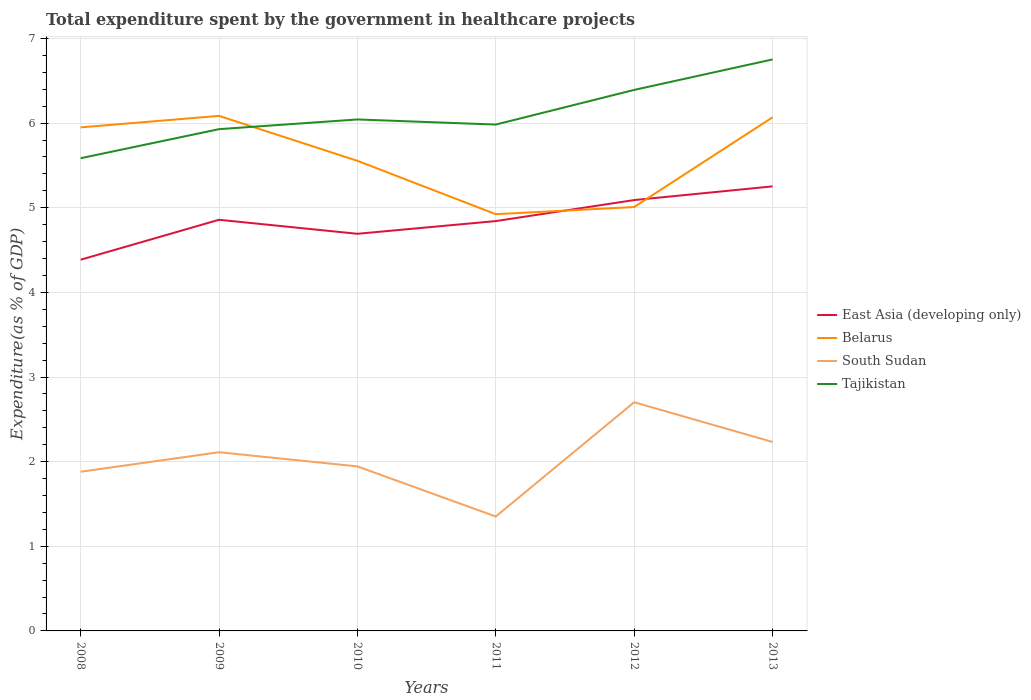Is the number of lines equal to the number of legend labels?
Your answer should be very brief. Yes. Across all years, what is the maximum total expenditure spent by the government in healthcare projects in Tajikistan?
Provide a succinct answer. 5.58. In which year was the total expenditure spent by the government in healthcare projects in Tajikistan maximum?
Ensure brevity in your answer.  2008. What is the total total expenditure spent by the government in healthcare projects in Tajikistan in the graph?
Offer a very short reply. -0.36. What is the difference between the highest and the second highest total expenditure spent by the government in healthcare projects in East Asia (developing only)?
Provide a succinct answer. 0.87. Is the total expenditure spent by the government in healthcare projects in East Asia (developing only) strictly greater than the total expenditure spent by the government in healthcare projects in Tajikistan over the years?
Your answer should be very brief. Yes. How many lines are there?
Offer a terse response. 4. What is the difference between two consecutive major ticks on the Y-axis?
Keep it short and to the point. 1. Does the graph contain any zero values?
Ensure brevity in your answer.  No. Where does the legend appear in the graph?
Offer a terse response. Center right. What is the title of the graph?
Give a very brief answer. Total expenditure spent by the government in healthcare projects. What is the label or title of the X-axis?
Offer a very short reply. Years. What is the label or title of the Y-axis?
Keep it short and to the point. Expenditure(as % of GDP). What is the Expenditure(as % of GDP) in East Asia (developing only) in 2008?
Your answer should be very brief. 4.39. What is the Expenditure(as % of GDP) in Belarus in 2008?
Ensure brevity in your answer.  5.95. What is the Expenditure(as % of GDP) of South Sudan in 2008?
Provide a succinct answer. 1.88. What is the Expenditure(as % of GDP) in Tajikistan in 2008?
Keep it short and to the point. 5.58. What is the Expenditure(as % of GDP) in East Asia (developing only) in 2009?
Make the answer very short. 4.86. What is the Expenditure(as % of GDP) of Belarus in 2009?
Provide a succinct answer. 6.09. What is the Expenditure(as % of GDP) of South Sudan in 2009?
Your response must be concise. 2.11. What is the Expenditure(as % of GDP) in Tajikistan in 2009?
Offer a very short reply. 5.93. What is the Expenditure(as % of GDP) of East Asia (developing only) in 2010?
Offer a terse response. 4.69. What is the Expenditure(as % of GDP) in Belarus in 2010?
Make the answer very short. 5.55. What is the Expenditure(as % of GDP) in South Sudan in 2010?
Make the answer very short. 1.94. What is the Expenditure(as % of GDP) of Tajikistan in 2010?
Your answer should be very brief. 6.04. What is the Expenditure(as % of GDP) in East Asia (developing only) in 2011?
Give a very brief answer. 4.84. What is the Expenditure(as % of GDP) in Belarus in 2011?
Provide a succinct answer. 4.92. What is the Expenditure(as % of GDP) in South Sudan in 2011?
Make the answer very short. 1.35. What is the Expenditure(as % of GDP) in Tajikistan in 2011?
Your response must be concise. 5.98. What is the Expenditure(as % of GDP) of East Asia (developing only) in 2012?
Your answer should be compact. 5.09. What is the Expenditure(as % of GDP) in Belarus in 2012?
Keep it short and to the point. 5.01. What is the Expenditure(as % of GDP) of South Sudan in 2012?
Give a very brief answer. 2.7. What is the Expenditure(as % of GDP) in Tajikistan in 2012?
Your answer should be compact. 6.39. What is the Expenditure(as % of GDP) in East Asia (developing only) in 2013?
Ensure brevity in your answer.  5.25. What is the Expenditure(as % of GDP) in Belarus in 2013?
Offer a terse response. 6.07. What is the Expenditure(as % of GDP) in South Sudan in 2013?
Your response must be concise. 2.23. What is the Expenditure(as % of GDP) of Tajikistan in 2013?
Your response must be concise. 6.75. Across all years, what is the maximum Expenditure(as % of GDP) in East Asia (developing only)?
Make the answer very short. 5.25. Across all years, what is the maximum Expenditure(as % of GDP) of Belarus?
Ensure brevity in your answer.  6.09. Across all years, what is the maximum Expenditure(as % of GDP) of South Sudan?
Give a very brief answer. 2.7. Across all years, what is the maximum Expenditure(as % of GDP) in Tajikistan?
Give a very brief answer. 6.75. Across all years, what is the minimum Expenditure(as % of GDP) in East Asia (developing only)?
Ensure brevity in your answer.  4.39. Across all years, what is the minimum Expenditure(as % of GDP) of Belarus?
Your answer should be very brief. 4.92. Across all years, what is the minimum Expenditure(as % of GDP) in South Sudan?
Provide a succinct answer. 1.35. Across all years, what is the minimum Expenditure(as % of GDP) of Tajikistan?
Your answer should be very brief. 5.58. What is the total Expenditure(as % of GDP) in East Asia (developing only) in the graph?
Offer a terse response. 29.12. What is the total Expenditure(as % of GDP) of Belarus in the graph?
Offer a very short reply. 33.59. What is the total Expenditure(as % of GDP) in South Sudan in the graph?
Make the answer very short. 12.22. What is the total Expenditure(as % of GDP) in Tajikistan in the graph?
Ensure brevity in your answer.  36.68. What is the difference between the Expenditure(as % of GDP) of East Asia (developing only) in 2008 and that in 2009?
Provide a short and direct response. -0.47. What is the difference between the Expenditure(as % of GDP) of Belarus in 2008 and that in 2009?
Provide a short and direct response. -0.14. What is the difference between the Expenditure(as % of GDP) in South Sudan in 2008 and that in 2009?
Your answer should be compact. -0.23. What is the difference between the Expenditure(as % of GDP) of Tajikistan in 2008 and that in 2009?
Your answer should be very brief. -0.34. What is the difference between the Expenditure(as % of GDP) in East Asia (developing only) in 2008 and that in 2010?
Provide a succinct answer. -0.31. What is the difference between the Expenditure(as % of GDP) of Belarus in 2008 and that in 2010?
Offer a terse response. 0.4. What is the difference between the Expenditure(as % of GDP) in South Sudan in 2008 and that in 2010?
Offer a terse response. -0.06. What is the difference between the Expenditure(as % of GDP) of Tajikistan in 2008 and that in 2010?
Give a very brief answer. -0.46. What is the difference between the Expenditure(as % of GDP) of East Asia (developing only) in 2008 and that in 2011?
Your response must be concise. -0.46. What is the difference between the Expenditure(as % of GDP) of Belarus in 2008 and that in 2011?
Provide a short and direct response. 1.03. What is the difference between the Expenditure(as % of GDP) in South Sudan in 2008 and that in 2011?
Offer a terse response. 0.53. What is the difference between the Expenditure(as % of GDP) in Tajikistan in 2008 and that in 2011?
Provide a succinct answer. -0.4. What is the difference between the Expenditure(as % of GDP) of East Asia (developing only) in 2008 and that in 2012?
Provide a short and direct response. -0.7. What is the difference between the Expenditure(as % of GDP) in Belarus in 2008 and that in 2012?
Your answer should be compact. 0.94. What is the difference between the Expenditure(as % of GDP) in South Sudan in 2008 and that in 2012?
Ensure brevity in your answer.  -0.82. What is the difference between the Expenditure(as % of GDP) in Tajikistan in 2008 and that in 2012?
Give a very brief answer. -0.81. What is the difference between the Expenditure(as % of GDP) of East Asia (developing only) in 2008 and that in 2013?
Ensure brevity in your answer.  -0.87. What is the difference between the Expenditure(as % of GDP) of Belarus in 2008 and that in 2013?
Your response must be concise. -0.12. What is the difference between the Expenditure(as % of GDP) of South Sudan in 2008 and that in 2013?
Make the answer very short. -0.35. What is the difference between the Expenditure(as % of GDP) in Tajikistan in 2008 and that in 2013?
Your answer should be compact. -1.17. What is the difference between the Expenditure(as % of GDP) of East Asia (developing only) in 2009 and that in 2010?
Offer a terse response. 0.17. What is the difference between the Expenditure(as % of GDP) of Belarus in 2009 and that in 2010?
Offer a very short reply. 0.53. What is the difference between the Expenditure(as % of GDP) in South Sudan in 2009 and that in 2010?
Offer a terse response. 0.17. What is the difference between the Expenditure(as % of GDP) in Tajikistan in 2009 and that in 2010?
Provide a short and direct response. -0.11. What is the difference between the Expenditure(as % of GDP) of East Asia (developing only) in 2009 and that in 2011?
Make the answer very short. 0.02. What is the difference between the Expenditure(as % of GDP) in Belarus in 2009 and that in 2011?
Your answer should be compact. 1.16. What is the difference between the Expenditure(as % of GDP) in South Sudan in 2009 and that in 2011?
Ensure brevity in your answer.  0.76. What is the difference between the Expenditure(as % of GDP) of Tajikistan in 2009 and that in 2011?
Keep it short and to the point. -0.05. What is the difference between the Expenditure(as % of GDP) in East Asia (developing only) in 2009 and that in 2012?
Provide a succinct answer. -0.23. What is the difference between the Expenditure(as % of GDP) in Belarus in 2009 and that in 2012?
Give a very brief answer. 1.08. What is the difference between the Expenditure(as % of GDP) of South Sudan in 2009 and that in 2012?
Provide a short and direct response. -0.59. What is the difference between the Expenditure(as % of GDP) in Tajikistan in 2009 and that in 2012?
Provide a short and direct response. -0.46. What is the difference between the Expenditure(as % of GDP) of East Asia (developing only) in 2009 and that in 2013?
Provide a short and direct response. -0.39. What is the difference between the Expenditure(as % of GDP) of Belarus in 2009 and that in 2013?
Provide a succinct answer. 0.02. What is the difference between the Expenditure(as % of GDP) of South Sudan in 2009 and that in 2013?
Make the answer very short. -0.12. What is the difference between the Expenditure(as % of GDP) of Tajikistan in 2009 and that in 2013?
Offer a terse response. -0.82. What is the difference between the Expenditure(as % of GDP) in East Asia (developing only) in 2010 and that in 2011?
Make the answer very short. -0.15. What is the difference between the Expenditure(as % of GDP) in Belarus in 2010 and that in 2011?
Your answer should be very brief. 0.63. What is the difference between the Expenditure(as % of GDP) of South Sudan in 2010 and that in 2011?
Make the answer very short. 0.59. What is the difference between the Expenditure(as % of GDP) of Tajikistan in 2010 and that in 2011?
Offer a very short reply. 0.06. What is the difference between the Expenditure(as % of GDP) in East Asia (developing only) in 2010 and that in 2012?
Provide a succinct answer. -0.4. What is the difference between the Expenditure(as % of GDP) of Belarus in 2010 and that in 2012?
Ensure brevity in your answer.  0.55. What is the difference between the Expenditure(as % of GDP) of South Sudan in 2010 and that in 2012?
Keep it short and to the point. -0.76. What is the difference between the Expenditure(as % of GDP) in Tajikistan in 2010 and that in 2012?
Offer a terse response. -0.35. What is the difference between the Expenditure(as % of GDP) of East Asia (developing only) in 2010 and that in 2013?
Offer a very short reply. -0.56. What is the difference between the Expenditure(as % of GDP) of Belarus in 2010 and that in 2013?
Your answer should be compact. -0.51. What is the difference between the Expenditure(as % of GDP) of South Sudan in 2010 and that in 2013?
Offer a very short reply. -0.29. What is the difference between the Expenditure(as % of GDP) of Tajikistan in 2010 and that in 2013?
Offer a terse response. -0.71. What is the difference between the Expenditure(as % of GDP) in East Asia (developing only) in 2011 and that in 2012?
Make the answer very short. -0.25. What is the difference between the Expenditure(as % of GDP) in Belarus in 2011 and that in 2012?
Your response must be concise. -0.08. What is the difference between the Expenditure(as % of GDP) in South Sudan in 2011 and that in 2012?
Offer a terse response. -1.35. What is the difference between the Expenditure(as % of GDP) of Tajikistan in 2011 and that in 2012?
Your answer should be very brief. -0.41. What is the difference between the Expenditure(as % of GDP) in East Asia (developing only) in 2011 and that in 2013?
Give a very brief answer. -0.41. What is the difference between the Expenditure(as % of GDP) in Belarus in 2011 and that in 2013?
Ensure brevity in your answer.  -1.14. What is the difference between the Expenditure(as % of GDP) in South Sudan in 2011 and that in 2013?
Keep it short and to the point. -0.88. What is the difference between the Expenditure(as % of GDP) of Tajikistan in 2011 and that in 2013?
Ensure brevity in your answer.  -0.77. What is the difference between the Expenditure(as % of GDP) of East Asia (developing only) in 2012 and that in 2013?
Ensure brevity in your answer.  -0.16. What is the difference between the Expenditure(as % of GDP) of Belarus in 2012 and that in 2013?
Provide a succinct answer. -1.06. What is the difference between the Expenditure(as % of GDP) in South Sudan in 2012 and that in 2013?
Make the answer very short. 0.47. What is the difference between the Expenditure(as % of GDP) in Tajikistan in 2012 and that in 2013?
Give a very brief answer. -0.36. What is the difference between the Expenditure(as % of GDP) of East Asia (developing only) in 2008 and the Expenditure(as % of GDP) of Belarus in 2009?
Keep it short and to the point. -1.7. What is the difference between the Expenditure(as % of GDP) in East Asia (developing only) in 2008 and the Expenditure(as % of GDP) in South Sudan in 2009?
Provide a short and direct response. 2.27. What is the difference between the Expenditure(as % of GDP) in East Asia (developing only) in 2008 and the Expenditure(as % of GDP) in Tajikistan in 2009?
Provide a short and direct response. -1.54. What is the difference between the Expenditure(as % of GDP) in Belarus in 2008 and the Expenditure(as % of GDP) in South Sudan in 2009?
Make the answer very short. 3.84. What is the difference between the Expenditure(as % of GDP) in Belarus in 2008 and the Expenditure(as % of GDP) in Tajikistan in 2009?
Make the answer very short. 0.02. What is the difference between the Expenditure(as % of GDP) of South Sudan in 2008 and the Expenditure(as % of GDP) of Tajikistan in 2009?
Your answer should be compact. -4.05. What is the difference between the Expenditure(as % of GDP) of East Asia (developing only) in 2008 and the Expenditure(as % of GDP) of Belarus in 2010?
Provide a succinct answer. -1.17. What is the difference between the Expenditure(as % of GDP) in East Asia (developing only) in 2008 and the Expenditure(as % of GDP) in South Sudan in 2010?
Your answer should be compact. 2.44. What is the difference between the Expenditure(as % of GDP) of East Asia (developing only) in 2008 and the Expenditure(as % of GDP) of Tajikistan in 2010?
Offer a terse response. -1.66. What is the difference between the Expenditure(as % of GDP) in Belarus in 2008 and the Expenditure(as % of GDP) in South Sudan in 2010?
Your response must be concise. 4.01. What is the difference between the Expenditure(as % of GDP) of Belarus in 2008 and the Expenditure(as % of GDP) of Tajikistan in 2010?
Ensure brevity in your answer.  -0.09. What is the difference between the Expenditure(as % of GDP) in South Sudan in 2008 and the Expenditure(as % of GDP) in Tajikistan in 2010?
Offer a very short reply. -4.16. What is the difference between the Expenditure(as % of GDP) of East Asia (developing only) in 2008 and the Expenditure(as % of GDP) of Belarus in 2011?
Your answer should be very brief. -0.54. What is the difference between the Expenditure(as % of GDP) in East Asia (developing only) in 2008 and the Expenditure(as % of GDP) in South Sudan in 2011?
Offer a terse response. 3.03. What is the difference between the Expenditure(as % of GDP) of East Asia (developing only) in 2008 and the Expenditure(as % of GDP) of Tajikistan in 2011?
Ensure brevity in your answer.  -1.6. What is the difference between the Expenditure(as % of GDP) of Belarus in 2008 and the Expenditure(as % of GDP) of South Sudan in 2011?
Keep it short and to the point. 4.6. What is the difference between the Expenditure(as % of GDP) in Belarus in 2008 and the Expenditure(as % of GDP) in Tajikistan in 2011?
Keep it short and to the point. -0.03. What is the difference between the Expenditure(as % of GDP) in South Sudan in 2008 and the Expenditure(as % of GDP) in Tajikistan in 2011?
Ensure brevity in your answer.  -4.1. What is the difference between the Expenditure(as % of GDP) of East Asia (developing only) in 2008 and the Expenditure(as % of GDP) of Belarus in 2012?
Provide a succinct answer. -0.62. What is the difference between the Expenditure(as % of GDP) of East Asia (developing only) in 2008 and the Expenditure(as % of GDP) of South Sudan in 2012?
Keep it short and to the point. 1.68. What is the difference between the Expenditure(as % of GDP) of East Asia (developing only) in 2008 and the Expenditure(as % of GDP) of Tajikistan in 2012?
Offer a terse response. -2.01. What is the difference between the Expenditure(as % of GDP) in Belarus in 2008 and the Expenditure(as % of GDP) in South Sudan in 2012?
Provide a succinct answer. 3.25. What is the difference between the Expenditure(as % of GDP) in Belarus in 2008 and the Expenditure(as % of GDP) in Tajikistan in 2012?
Offer a very short reply. -0.44. What is the difference between the Expenditure(as % of GDP) of South Sudan in 2008 and the Expenditure(as % of GDP) of Tajikistan in 2012?
Your answer should be compact. -4.51. What is the difference between the Expenditure(as % of GDP) of East Asia (developing only) in 2008 and the Expenditure(as % of GDP) of Belarus in 2013?
Keep it short and to the point. -1.68. What is the difference between the Expenditure(as % of GDP) of East Asia (developing only) in 2008 and the Expenditure(as % of GDP) of South Sudan in 2013?
Offer a terse response. 2.15. What is the difference between the Expenditure(as % of GDP) in East Asia (developing only) in 2008 and the Expenditure(as % of GDP) in Tajikistan in 2013?
Ensure brevity in your answer.  -2.37. What is the difference between the Expenditure(as % of GDP) of Belarus in 2008 and the Expenditure(as % of GDP) of South Sudan in 2013?
Offer a very short reply. 3.72. What is the difference between the Expenditure(as % of GDP) of Belarus in 2008 and the Expenditure(as % of GDP) of Tajikistan in 2013?
Keep it short and to the point. -0.8. What is the difference between the Expenditure(as % of GDP) of South Sudan in 2008 and the Expenditure(as % of GDP) of Tajikistan in 2013?
Your response must be concise. -4.87. What is the difference between the Expenditure(as % of GDP) of East Asia (developing only) in 2009 and the Expenditure(as % of GDP) of Belarus in 2010?
Provide a short and direct response. -0.7. What is the difference between the Expenditure(as % of GDP) of East Asia (developing only) in 2009 and the Expenditure(as % of GDP) of South Sudan in 2010?
Provide a short and direct response. 2.91. What is the difference between the Expenditure(as % of GDP) in East Asia (developing only) in 2009 and the Expenditure(as % of GDP) in Tajikistan in 2010?
Keep it short and to the point. -1.19. What is the difference between the Expenditure(as % of GDP) of Belarus in 2009 and the Expenditure(as % of GDP) of South Sudan in 2010?
Offer a terse response. 4.14. What is the difference between the Expenditure(as % of GDP) of Belarus in 2009 and the Expenditure(as % of GDP) of Tajikistan in 2010?
Provide a short and direct response. 0.04. What is the difference between the Expenditure(as % of GDP) in South Sudan in 2009 and the Expenditure(as % of GDP) in Tajikistan in 2010?
Your answer should be very brief. -3.93. What is the difference between the Expenditure(as % of GDP) in East Asia (developing only) in 2009 and the Expenditure(as % of GDP) in Belarus in 2011?
Offer a very short reply. -0.07. What is the difference between the Expenditure(as % of GDP) in East Asia (developing only) in 2009 and the Expenditure(as % of GDP) in South Sudan in 2011?
Give a very brief answer. 3.51. What is the difference between the Expenditure(as % of GDP) of East Asia (developing only) in 2009 and the Expenditure(as % of GDP) of Tajikistan in 2011?
Provide a short and direct response. -1.12. What is the difference between the Expenditure(as % of GDP) in Belarus in 2009 and the Expenditure(as % of GDP) in South Sudan in 2011?
Ensure brevity in your answer.  4.73. What is the difference between the Expenditure(as % of GDP) in Belarus in 2009 and the Expenditure(as % of GDP) in Tajikistan in 2011?
Give a very brief answer. 0.1. What is the difference between the Expenditure(as % of GDP) in South Sudan in 2009 and the Expenditure(as % of GDP) in Tajikistan in 2011?
Your answer should be compact. -3.87. What is the difference between the Expenditure(as % of GDP) in East Asia (developing only) in 2009 and the Expenditure(as % of GDP) in Belarus in 2012?
Ensure brevity in your answer.  -0.15. What is the difference between the Expenditure(as % of GDP) in East Asia (developing only) in 2009 and the Expenditure(as % of GDP) in South Sudan in 2012?
Provide a succinct answer. 2.16. What is the difference between the Expenditure(as % of GDP) of East Asia (developing only) in 2009 and the Expenditure(as % of GDP) of Tajikistan in 2012?
Keep it short and to the point. -1.53. What is the difference between the Expenditure(as % of GDP) in Belarus in 2009 and the Expenditure(as % of GDP) in South Sudan in 2012?
Ensure brevity in your answer.  3.38. What is the difference between the Expenditure(as % of GDP) in Belarus in 2009 and the Expenditure(as % of GDP) in Tajikistan in 2012?
Give a very brief answer. -0.31. What is the difference between the Expenditure(as % of GDP) in South Sudan in 2009 and the Expenditure(as % of GDP) in Tajikistan in 2012?
Offer a terse response. -4.28. What is the difference between the Expenditure(as % of GDP) in East Asia (developing only) in 2009 and the Expenditure(as % of GDP) in Belarus in 2013?
Your answer should be compact. -1.21. What is the difference between the Expenditure(as % of GDP) in East Asia (developing only) in 2009 and the Expenditure(as % of GDP) in South Sudan in 2013?
Offer a terse response. 2.63. What is the difference between the Expenditure(as % of GDP) of East Asia (developing only) in 2009 and the Expenditure(as % of GDP) of Tajikistan in 2013?
Offer a terse response. -1.89. What is the difference between the Expenditure(as % of GDP) in Belarus in 2009 and the Expenditure(as % of GDP) in South Sudan in 2013?
Ensure brevity in your answer.  3.85. What is the difference between the Expenditure(as % of GDP) of Belarus in 2009 and the Expenditure(as % of GDP) of Tajikistan in 2013?
Keep it short and to the point. -0.67. What is the difference between the Expenditure(as % of GDP) in South Sudan in 2009 and the Expenditure(as % of GDP) in Tajikistan in 2013?
Offer a terse response. -4.64. What is the difference between the Expenditure(as % of GDP) of East Asia (developing only) in 2010 and the Expenditure(as % of GDP) of Belarus in 2011?
Your response must be concise. -0.23. What is the difference between the Expenditure(as % of GDP) in East Asia (developing only) in 2010 and the Expenditure(as % of GDP) in South Sudan in 2011?
Ensure brevity in your answer.  3.34. What is the difference between the Expenditure(as % of GDP) in East Asia (developing only) in 2010 and the Expenditure(as % of GDP) in Tajikistan in 2011?
Ensure brevity in your answer.  -1.29. What is the difference between the Expenditure(as % of GDP) in Belarus in 2010 and the Expenditure(as % of GDP) in South Sudan in 2011?
Provide a succinct answer. 4.2. What is the difference between the Expenditure(as % of GDP) in Belarus in 2010 and the Expenditure(as % of GDP) in Tajikistan in 2011?
Provide a succinct answer. -0.43. What is the difference between the Expenditure(as % of GDP) of South Sudan in 2010 and the Expenditure(as % of GDP) of Tajikistan in 2011?
Offer a very short reply. -4.04. What is the difference between the Expenditure(as % of GDP) in East Asia (developing only) in 2010 and the Expenditure(as % of GDP) in Belarus in 2012?
Ensure brevity in your answer.  -0.32. What is the difference between the Expenditure(as % of GDP) of East Asia (developing only) in 2010 and the Expenditure(as % of GDP) of South Sudan in 2012?
Give a very brief answer. 1.99. What is the difference between the Expenditure(as % of GDP) of Belarus in 2010 and the Expenditure(as % of GDP) of South Sudan in 2012?
Offer a terse response. 2.85. What is the difference between the Expenditure(as % of GDP) in Belarus in 2010 and the Expenditure(as % of GDP) in Tajikistan in 2012?
Keep it short and to the point. -0.84. What is the difference between the Expenditure(as % of GDP) of South Sudan in 2010 and the Expenditure(as % of GDP) of Tajikistan in 2012?
Your response must be concise. -4.45. What is the difference between the Expenditure(as % of GDP) of East Asia (developing only) in 2010 and the Expenditure(as % of GDP) of Belarus in 2013?
Ensure brevity in your answer.  -1.38. What is the difference between the Expenditure(as % of GDP) in East Asia (developing only) in 2010 and the Expenditure(as % of GDP) in South Sudan in 2013?
Make the answer very short. 2.46. What is the difference between the Expenditure(as % of GDP) in East Asia (developing only) in 2010 and the Expenditure(as % of GDP) in Tajikistan in 2013?
Make the answer very short. -2.06. What is the difference between the Expenditure(as % of GDP) in Belarus in 2010 and the Expenditure(as % of GDP) in South Sudan in 2013?
Provide a short and direct response. 3.32. What is the difference between the Expenditure(as % of GDP) in Belarus in 2010 and the Expenditure(as % of GDP) in Tajikistan in 2013?
Your answer should be very brief. -1.2. What is the difference between the Expenditure(as % of GDP) of South Sudan in 2010 and the Expenditure(as % of GDP) of Tajikistan in 2013?
Make the answer very short. -4.81. What is the difference between the Expenditure(as % of GDP) in East Asia (developing only) in 2011 and the Expenditure(as % of GDP) in Belarus in 2012?
Give a very brief answer. -0.17. What is the difference between the Expenditure(as % of GDP) of East Asia (developing only) in 2011 and the Expenditure(as % of GDP) of South Sudan in 2012?
Your answer should be compact. 2.14. What is the difference between the Expenditure(as % of GDP) in East Asia (developing only) in 2011 and the Expenditure(as % of GDP) in Tajikistan in 2012?
Provide a short and direct response. -1.55. What is the difference between the Expenditure(as % of GDP) in Belarus in 2011 and the Expenditure(as % of GDP) in South Sudan in 2012?
Provide a short and direct response. 2.22. What is the difference between the Expenditure(as % of GDP) in Belarus in 2011 and the Expenditure(as % of GDP) in Tajikistan in 2012?
Your answer should be compact. -1.47. What is the difference between the Expenditure(as % of GDP) in South Sudan in 2011 and the Expenditure(as % of GDP) in Tajikistan in 2012?
Make the answer very short. -5.04. What is the difference between the Expenditure(as % of GDP) of East Asia (developing only) in 2011 and the Expenditure(as % of GDP) of Belarus in 2013?
Your answer should be compact. -1.23. What is the difference between the Expenditure(as % of GDP) of East Asia (developing only) in 2011 and the Expenditure(as % of GDP) of South Sudan in 2013?
Offer a terse response. 2.61. What is the difference between the Expenditure(as % of GDP) of East Asia (developing only) in 2011 and the Expenditure(as % of GDP) of Tajikistan in 2013?
Your answer should be compact. -1.91. What is the difference between the Expenditure(as % of GDP) of Belarus in 2011 and the Expenditure(as % of GDP) of South Sudan in 2013?
Your answer should be very brief. 2.69. What is the difference between the Expenditure(as % of GDP) of Belarus in 2011 and the Expenditure(as % of GDP) of Tajikistan in 2013?
Your answer should be compact. -1.83. What is the difference between the Expenditure(as % of GDP) of South Sudan in 2011 and the Expenditure(as % of GDP) of Tajikistan in 2013?
Provide a succinct answer. -5.4. What is the difference between the Expenditure(as % of GDP) of East Asia (developing only) in 2012 and the Expenditure(as % of GDP) of Belarus in 2013?
Make the answer very short. -0.98. What is the difference between the Expenditure(as % of GDP) in East Asia (developing only) in 2012 and the Expenditure(as % of GDP) in South Sudan in 2013?
Offer a very short reply. 2.86. What is the difference between the Expenditure(as % of GDP) of East Asia (developing only) in 2012 and the Expenditure(as % of GDP) of Tajikistan in 2013?
Offer a terse response. -1.66. What is the difference between the Expenditure(as % of GDP) in Belarus in 2012 and the Expenditure(as % of GDP) in South Sudan in 2013?
Keep it short and to the point. 2.78. What is the difference between the Expenditure(as % of GDP) of Belarus in 2012 and the Expenditure(as % of GDP) of Tajikistan in 2013?
Make the answer very short. -1.74. What is the difference between the Expenditure(as % of GDP) of South Sudan in 2012 and the Expenditure(as % of GDP) of Tajikistan in 2013?
Provide a short and direct response. -4.05. What is the average Expenditure(as % of GDP) in East Asia (developing only) per year?
Provide a short and direct response. 4.85. What is the average Expenditure(as % of GDP) of Belarus per year?
Provide a short and direct response. 5.6. What is the average Expenditure(as % of GDP) of South Sudan per year?
Offer a very short reply. 2.04. What is the average Expenditure(as % of GDP) of Tajikistan per year?
Your answer should be very brief. 6.11. In the year 2008, what is the difference between the Expenditure(as % of GDP) of East Asia (developing only) and Expenditure(as % of GDP) of Belarus?
Provide a short and direct response. -1.56. In the year 2008, what is the difference between the Expenditure(as % of GDP) of East Asia (developing only) and Expenditure(as % of GDP) of South Sudan?
Offer a terse response. 2.51. In the year 2008, what is the difference between the Expenditure(as % of GDP) in East Asia (developing only) and Expenditure(as % of GDP) in Tajikistan?
Provide a succinct answer. -1.2. In the year 2008, what is the difference between the Expenditure(as % of GDP) in Belarus and Expenditure(as % of GDP) in South Sudan?
Offer a very short reply. 4.07. In the year 2008, what is the difference between the Expenditure(as % of GDP) of Belarus and Expenditure(as % of GDP) of Tajikistan?
Offer a terse response. 0.36. In the year 2008, what is the difference between the Expenditure(as % of GDP) of South Sudan and Expenditure(as % of GDP) of Tajikistan?
Offer a very short reply. -3.7. In the year 2009, what is the difference between the Expenditure(as % of GDP) in East Asia (developing only) and Expenditure(as % of GDP) in Belarus?
Keep it short and to the point. -1.23. In the year 2009, what is the difference between the Expenditure(as % of GDP) in East Asia (developing only) and Expenditure(as % of GDP) in South Sudan?
Your answer should be very brief. 2.75. In the year 2009, what is the difference between the Expenditure(as % of GDP) of East Asia (developing only) and Expenditure(as % of GDP) of Tajikistan?
Your answer should be compact. -1.07. In the year 2009, what is the difference between the Expenditure(as % of GDP) in Belarus and Expenditure(as % of GDP) in South Sudan?
Your answer should be very brief. 3.97. In the year 2009, what is the difference between the Expenditure(as % of GDP) in Belarus and Expenditure(as % of GDP) in Tajikistan?
Your response must be concise. 0.16. In the year 2009, what is the difference between the Expenditure(as % of GDP) of South Sudan and Expenditure(as % of GDP) of Tajikistan?
Your answer should be very brief. -3.82. In the year 2010, what is the difference between the Expenditure(as % of GDP) in East Asia (developing only) and Expenditure(as % of GDP) in Belarus?
Ensure brevity in your answer.  -0.86. In the year 2010, what is the difference between the Expenditure(as % of GDP) of East Asia (developing only) and Expenditure(as % of GDP) of South Sudan?
Make the answer very short. 2.75. In the year 2010, what is the difference between the Expenditure(as % of GDP) in East Asia (developing only) and Expenditure(as % of GDP) in Tajikistan?
Your answer should be very brief. -1.35. In the year 2010, what is the difference between the Expenditure(as % of GDP) in Belarus and Expenditure(as % of GDP) in South Sudan?
Your response must be concise. 3.61. In the year 2010, what is the difference between the Expenditure(as % of GDP) of Belarus and Expenditure(as % of GDP) of Tajikistan?
Keep it short and to the point. -0.49. In the year 2010, what is the difference between the Expenditure(as % of GDP) of South Sudan and Expenditure(as % of GDP) of Tajikistan?
Provide a succinct answer. -4.1. In the year 2011, what is the difference between the Expenditure(as % of GDP) in East Asia (developing only) and Expenditure(as % of GDP) in Belarus?
Provide a short and direct response. -0.08. In the year 2011, what is the difference between the Expenditure(as % of GDP) of East Asia (developing only) and Expenditure(as % of GDP) of South Sudan?
Your answer should be compact. 3.49. In the year 2011, what is the difference between the Expenditure(as % of GDP) in East Asia (developing only) and Expenditure(as % of GDP) in Tajikistan?
Provide a short and direct response. -1.14. In the year 2011, what is the difference between the Expenditure(as % of GDP) in Belarus and Expenditure(as % of GDP) in South Sudan?
Keep it short and to the point. 3.57. In the year 2011, what is the difference between the Expenditure(as % of GDP) of Belarus and Expenditure(as % of GDP) of Tajikistan?
Give a very brief answer. -1.06. In the year 2011, what is the difference between the Expenditure(as % of GDP) in South Sudan and Expenditure(as % of GDP) in Tajikistan?
Provide a succinct answer. -4.63. In the year 2012, what is the difference between the Expenditure(as % of GDP) of East Asia (developing only) and Expenditure(as % of GDP) of Belarus?
Your answer should be compact. 0.08. In the year 2012, what is the difference between the Expenditure(as % of GDP) in East Asia (developing only) and Expenditure(as % of GDP) in South Sudan?
Make the answer very short. 2.39. In the year 2012, what is the difference between the Expenditure(as % of GDP) of East Asia (developing only) and Expenditure(as % of GDP) of Tajikistan?
Your answer should be very brief. -1.3. In the year 2012, what is the difference between the Expenditure(as % of GDP) in Belarus and Expenditure(as % of GDP) in South Sudan?
Ensure brevity in your answer.  2.31. In the year 2012, what is the difference between the Expenditure(as % of GDP) of Belarus and Expenditure(as % of GDP) of Tajikistan?
Your answer should be compact. -1.38. In the year 2012, what is the difference between the Expenditure(as % of GDP) in South Sudan and Expenditure(as % of GDP) in Tajikistan?
Your answer should be compact. -3.69. In the year 2013, what is the difference between the Expenditure(as % of GDP) of East Asia (developing only) and Expenditure(as % of GDP) of Belarus?
Provide a succinct answer. -0.82. In the year 2013, what is the difference between the Expenditure(as % of GDP) of East Asia (developing only) and Expenditure(as % of GDP) of South Sudan?
Your answer should be very brief. 3.02. In the year 2013, what is the difference between the Expenditure(as % of GDP) of East Asia (developing only) and Expenditure(as % of GDP) of Tajikistan?
Give a very brief answer. -1.5. In the year 2013, what is the difference between the Expenditure(as % of GDP) of Belarus and Expenditure(as % of GDP) of South Sudan?
Your answer should be very brief. 3.84. In the year 2013, what is the difference between the Expenditure(as % of GDP) of Belarus and Expenditure(as % of GDP) of Tajikistan?
Ensure brevity in your answer.  -0.68. In the year 2013, what is the difference between the Expenditure(as % of GDP) in South Sudan and Expenditure(as % of GDP) in Tajikistan?
Give a very brief answer. -4.52. What is the ratio of the Expenditure(as % of GDP) in East Asia (developing only) in 2008 to that in 2009?
Ensure brevity in your answer.  0.9. What is the ratio of the Expenditure(as % of GDP) in Belarus in 2008 to that in 2009?
Provide a succinct answer. 0.98. What is the ratio of the Expenditure(as % of GDP) of South Sudan in 2008 to that in 2009?
Offer a terse response. 0.89. What is the ratio of the Expenditure(as % of GDP) of Tajikistan in 2008 to that in 2009?
Give a very brief answer. 0.94. What is the ratio of the Expenditure(as % of GDP) of East Asia (developing only) in 2008 to that in 2010?
Provide a short and direct response. 0.93. What is the ratio of the Expenditure(as % of GDP) of Belarus in 2008 to that in 2010?
Offer a very short reply. 1.07. What is the ratio of the Expenditure(as % of GDP) in South Sudan in 2008 to that in 2010?
Ensure brevity in your answer.  0.97. What is the ratio of the Expenditure(as % of GDP) of Tajikistan in 2008 to that in 2010?
Keep it short and to the point. 0.92. What is the ratio of the Expenditure(as % of GDP) in East Asia (developing only) in 2008 to that in 2011?
Provide a succinct answer. 0.91. What is the ratio of the Expenditure(as % of GDP) of Belarus in 2008 to that in 2011?
Ensure brevity in your answer.  1.21. What is the ratio of the Expenditure(as % of GDP) of South Sudan in 2008 to that in 2011?
Offer a very short reply. 1.39. What is the ratio of the Expenditure(as % of GDP) in Tajikistan in 2008 to that in 2011?
Give a very brief answer. 0.93. What is the ratio of the Expenditure(as % of GDP) of East Asia (developing only) in 2008 to that in 2012?
Make the answer very short. 0.86. What is the ratio of the Expenditure(as % of GDP) of Belarus in 2008 to that in 2012?
Make the answer very short. 1.19. What is the ratio of the Expenditure(as % of GDP) of South Sudan in 2008 to that in 2012?
Offer a very short reply. 0.7. What is the ratio of the Expenditure(as % of GDP) of Tajikistan in 2008 to that in 2012?
Your answer should be compact. 0.87. What is the ratio of the Expenditure(as % of GDP) in East Asia (developing only) in 2008 to that in 2013?
Provide a short and direct response. 0.83. What is the ratio of the Expenditure(as % of GDP) in Belarus in 2008 to that in 2013?
Your answer should be very brief. 0.98. What is the ratio of the Expenditure(as % of GDP) of South Sudan in 2008 to that in 2013?
Make the answer very short. 0.84. What is the ratio of the Expenditure(as % of GDP) in Tajikistan in 2008 to that in 2013?
Offer a terse response. 0.83. What is the ratio of the Expenditure(as % of GDP) of East Asia (developing only) in 2009 to that in 2010?
Offer a very short reply. 1.04. What is the ratio of the Expenditure(as % of GDP) of Belarus in 2009 to that in 2010?
Your response must be concise. 1.1. What is the ratio of the Expenditure(as % of GDP) of South Sudan in 2009 to that in 2010?
Your response must be concise. 1.09. What is the ratio of the Expenditure(as % of GDP) of Tajikistan in 2009 to that in 2010?
Give a very brief answer. 0.98. What is the ratio of the Expenditure(as % of GDP) in Belarus in 2009 to that in 2011?
Provide a short and direct response. 1.24. What is the ratio of the Expenditure(as % of GDP) in South Sudan in 2009 to that in 2011?
Offer a terse response. 1.56. What is the ratio of the Expenditure(as % of GDP) of Tajikistan in 2009 to that in 2011?
Provide a succinct answer. 0.99. What is the ratio of the Expenditure(as % of GDP) in East Asia (developing only) in 2009 to that in 2012?
Your response must be concise. 0.95. What is the ratio of the Expenditure(as % of GDP) in Belarus in 2009 to that in 2012?
Your response must be concise. 1.22. What is the ratio of the Expenditure(as % of GDP) in South Sudan in 2009 to that in 2012?
Keep it short and to the point. 0.78. What is the ratio of the Expenditure(as % of GDP) in Tajikistan in 2009 to that in 2012?
Offer a terse response. 0.93. What is the ratio of the Expenditure(as % of GDP) of East Asia (developing only) in 2009 to that in 2013?
Your answer should be compact. 0.92. What is the ratio of the Expenditure(as % of GDP) in South Sudan in 2009 to that in 2013?
Offer a very short reply. 0.95. What is the ratio of the Expenditure(as % of GDP) in Tajikistan in 2009 to that in 2013?
Provide a succinct answer. 0.88. What is the ratio of the Expenditure(as % of GDP) of East Asia (developing only) in 2010 to that in 2011?
Your answer should be very brief. 0.97. What is the ratio of the Expenditure(as % of GDP) in Belarus in 2010 to that in 2011?
Ensure brevity in your answer.  1.13. What is the ratio of the Expenditure(as % of GDP) in South Sudan in 2010 to that in 2011?
Provide a short and direct response. 1.44. What is the ratio of the Expenditure(as % of GDP) of Tajikistan in 2010 to that in 2011?
Provide a short and direct response. 1.01. What is the ratio of the Expenditure(as % of GDP) of East Asia (developing only) in 2010 to that in 2012?
Provide a succinct answer. 0.92. What is the ratio of the Expenditure(as % of GDP) in Belarus in 2010 to that in 2012?
Keep it short and to the point. 1.11. What is the ratio of the Expenditure(as % of GDP) of South Sudan in 2010 to that in 2012?
Keep it short and to the point. 0.72. What is the ratio of the Expenditure(as % of GDP) of Tajikistan in 2010 to that in 2012?
Provide a succinct answer. 0.95. What is the ratio of the Expenditure(as % of GDP) in East Asia (developing only) in 2010 to that in 2013?
Ensure brevity in your answer.  0.89. What is the ratio of the Expenditure(as % of GDP) in Belarus in 2010 to that in 2013?
Ensure brevity in your answer.  0.92. What is the ratio of the Expenditure(as % of GDP) in South Sudan in 2010 to that in 2013?
Ensure brevity in your answer.  0.87. What is the ratio of the Expenditure(as % of GDP) of Tajikistan in 2010 to that in 2013?
Offer a very short reply. 0.9. What is the ratio of the Expenditure(as % of GDP) of East Asia (developing only) in 2011 to that in 2012?
Provide a succinct answer. 0.95. What is the ratio of the Expenditure(as % of GDP) of Belarus in 2011 to that in 2012?
Offer a terse response. 0.98. What is the ratio of the Expenditure(as % of GDP) of South Sudan in 2011 to that in 2012?
Make the answer very short. 0.5. What is the ratio of the Expenditure(as % of GDP) of Tajikistan in 2011 to that in 2012?
Make the answer very short. 0.94. What is the ratio of the Expenditure(as % of GDP) of East Asia (developing only) in 2011 to that in 2013?
Keep it short and to the point. 0.92. What is the ratio of the Expenditure(as % of GDP) of Belarus in 2011 to that in 2013?
Your answer should be very brief. 0.81. What is the ratio of the Expenditure(as % of GDP) in South Sudan in 2011 to that in 2013?
Keep it short and to the point. 0.61. What is the ratio of the Expenditure(as % of GDP) in Tajikistan in 2011 to that in 2013?
Ensure brevity in your answer.  0.89. What is the ratio of the Expenditure(as % of GDP) of East Asia (developing only) in 2012 to that in 2013?
Offer a very short reply. 0.97. What is the ratio of the Expenditure(as % of GDP) of Belarus in 2012 to that in 2013?
Provide a short and direct response. 0.83. What is the ratio of the Expenditure(as % of GDP) in South Sudan in 2012 to that in 2013?
Your answer should be very brief. 1.21. What is the ratio of the Expenditure(as % of GDP) of Tajikistan in 2012 to that in 2013?
Your answer should be very brief. 0.95. What is the difference between the highest and the second highest Expenditure(as % of GDP) in East Asia (developing only)?
Give a very brief answer. 0.16. What is the difference between the highest and the second highest Expenditure(as % of GDP) of Belarus?
Your answer should be compact. 0.02. What is the difference between the highest and the second highest Expenditure(as % of GDP) in South Sudan?
Your answer should be compact. 0.47. What is the difference between the highest and the second highest Expenditure(as % of GDP) in Tajikistan?
Offer a terse response. 0.36. What is the difference between the highest and the lowest Expenditure(as % of GDP) in East Asia (developing only)?
Offer a very short reply. 0.87. What is the difference between the highest and the lowest Expenditure(as % of GDP) of Belarus?
Offer a terse response. 1.16. What is the difference between the highest and the lowest Expenditure(as % of GDP) in South Sudan?
Provide a short and direct response. 1.35. What is the difference between the highest and the lowest Expenditure(as % of GDP) in Tajikistan?
Offer a very short reply. 1.17. 